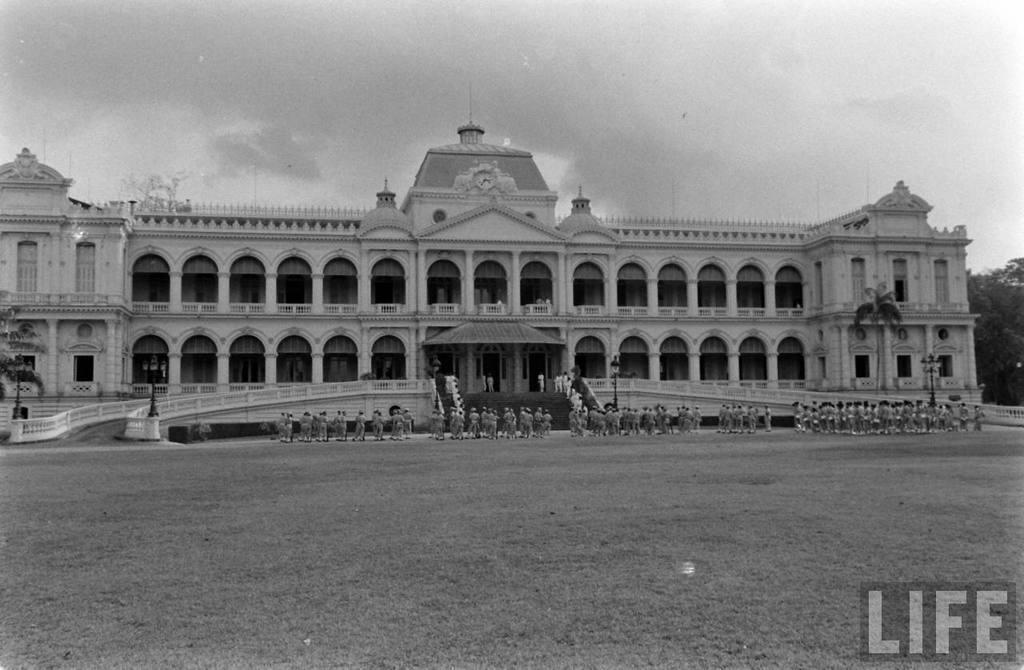How would you summarize this image in a sentence or two? In this picture I can see the building. in front of the building I can see many persons who are doing march. Beside them I can see the stairs, railing and poles. In the background I can see the trees. At the top I can see the sky and clouds. In the bottom right there is a watermark. 